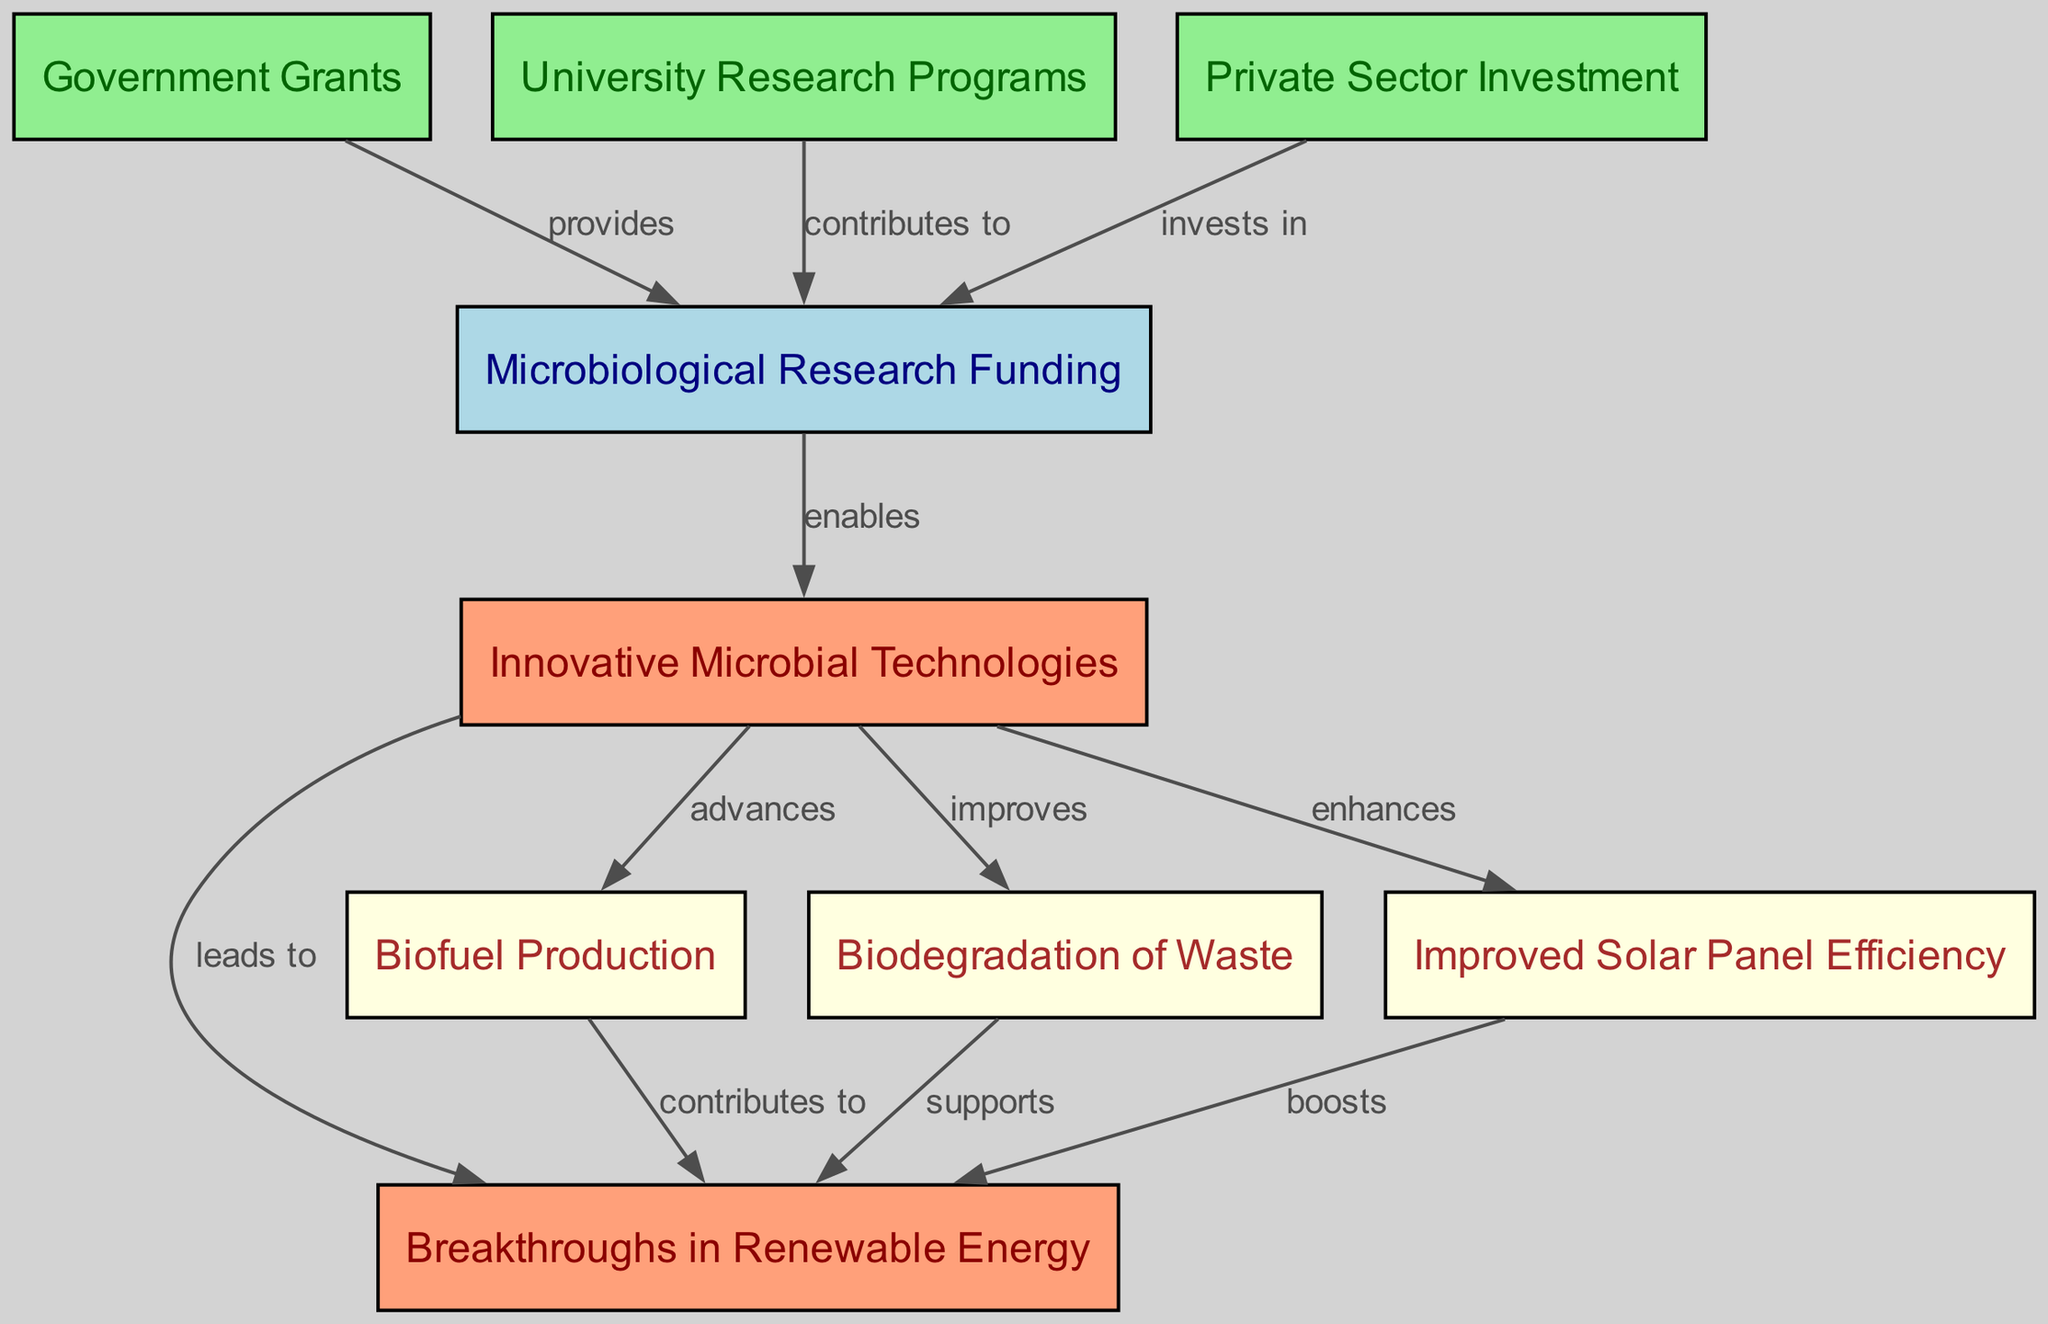What is the label of the first node? The first node's ID is "1", and according to the data provided, its label is "Microbiological Research Funding".
Answer: Microbiological Research Funding How many nodes are present in the diagram? By counting the number of nodes defined in the data, there are a total of 9 nodes.
Answer: 9 Which funding type contributes to microbiological research funding? The diagram indicates that both "Government Grants" and "University Research Programs" contribute to "Microbiological Research Funding".
Answer: Government Grants, University Research Programs What are the relationships between "Innovative Microbial Technologies" and "Breakthroughs in Renewable Energy"? The relationship shown in the diagram is that "Innovative Microbial Technologies" leads to "Breakthroughs in Renewable Energy", and also contributes to "Biofuel Production", "Biodegradation of Waste", and "Improved Solar Panel Efficiency".
Answer: Leads to, Advances, Improves, Enhances What is the relationship between "Private Sector Investment" and "Microbiological Research Funding"? The diagram states that "Private Sector Investment" invests in "Microbiological Research Funding".
Answer: Invests in Which outcome is enhanced by "Improved Solar Panel Efficiency"? According to the diagram, "Improved Solar Panel Efficiency" boosts "Breakthroughs in Renewable Energy".
Answer: Boosts Which node directly supports "Breakthroughs in Renewable Energy"? The node "Biodegradation of Waste" directly supports "Breakthroughs in Renewable Energy" based on the connections in the diagram.
Answer: Supports How many edges originate from the "Innovative Microbial Technologies" node? By reviewing the edges, there are four edges originating from the node "Innovative Microbial Technologies" that lead to other nodes.
Answer: 4 Which type of funding is represented by the color light green in the diagram? In the diagram, the color light green represents "Government Grants", "University Research Programs", and "Private Sector Investment".
Answer: Government Grants, University Research Programs, Private Sector Investment 